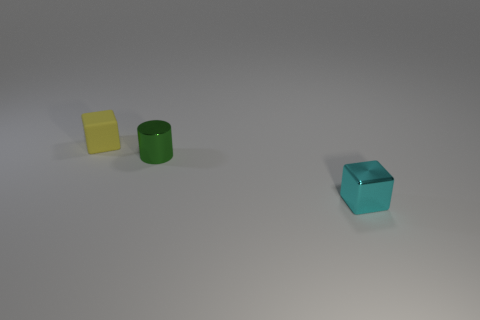Add 2 tiny cyan metal blocks. How many objects exist? 5 Subtract 2 cubes. How many cubes are left? 0 Subtract all yellow blocks. How many blocks are left? 1 Subtract all blocks. How many objects are left? 1 Subtract all brown blocks. Subtract all brown spheres. How many blocks are left? 2 Add 2 yellow matte things. How many yellow matte things are left? 3 Add 2 tiny green shiny cylinders. How many tiny green shiny cylinders exist? 3 Subtract 0 red blocks. How many objects are left? 3 Subtract all green balls. How many yellow blocks are left? 1 Subtract all small shiny cylinders. Subtract all matte things. How many objects are left? 1 